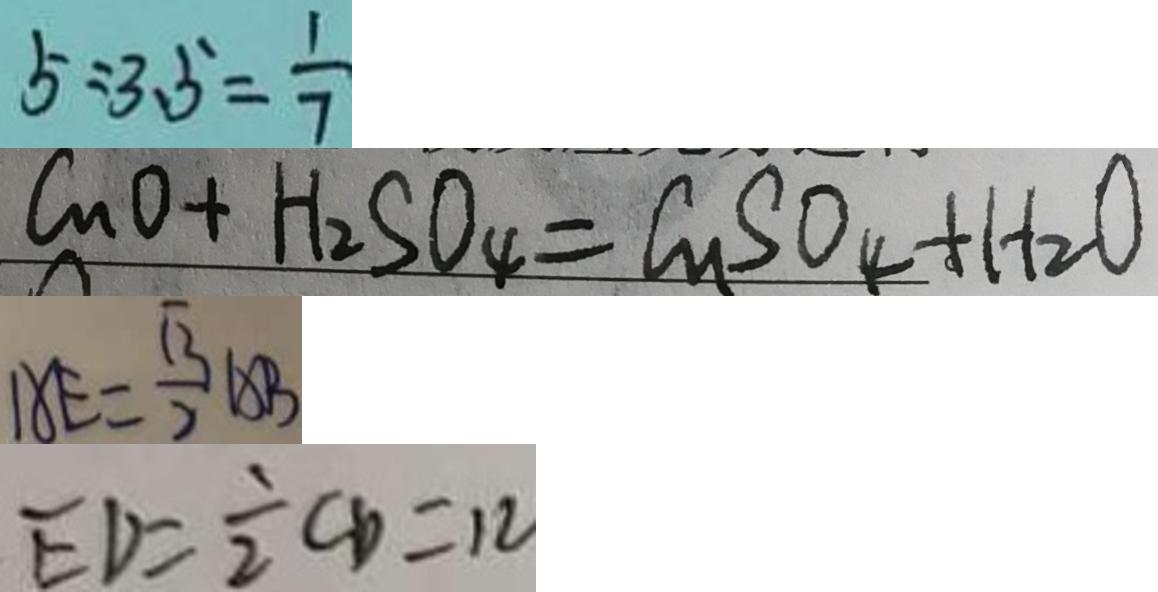<formula> <loc_0><loc_0><loc_500><loc_500>5 : 3 . 5 = \frac { 1 } { 7 } 
 C u O + H _ { 2 } S O _ { 4 } = C u S O _ { 4 } + H _ { 2 } O 
 A E = \frac { \sqrt { 3 } } { 2 } A B 
 E D = \frac { 1 } { 2 } C D = 1 2</formula> 